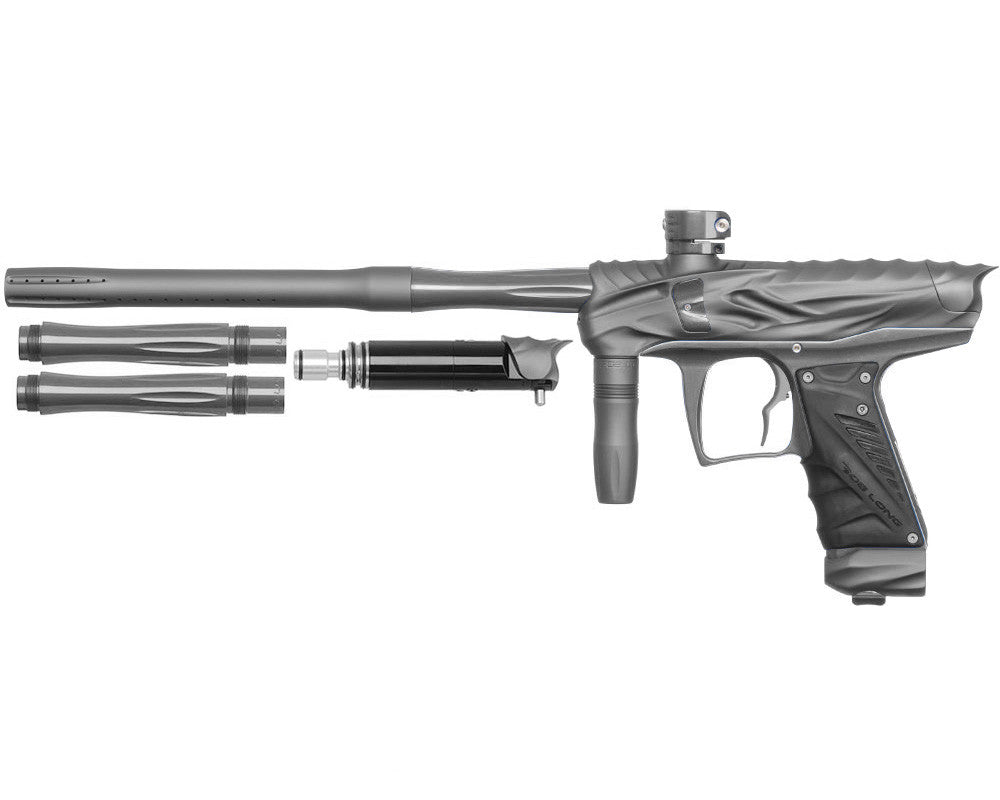Can you explain the benefit of having such a modular design in a paintball gun? The modular design of this paintball gun allows players to customize various components based on their playing style or the specific requirements of different game scenarios. By swapping out barrels, grips, or even the stock, users can adapt the gun's balance, weight, and shooting behavior. This versatility can significantly enhance a player's performance by allowing them to fine-tune the firearm to their exact needs. 